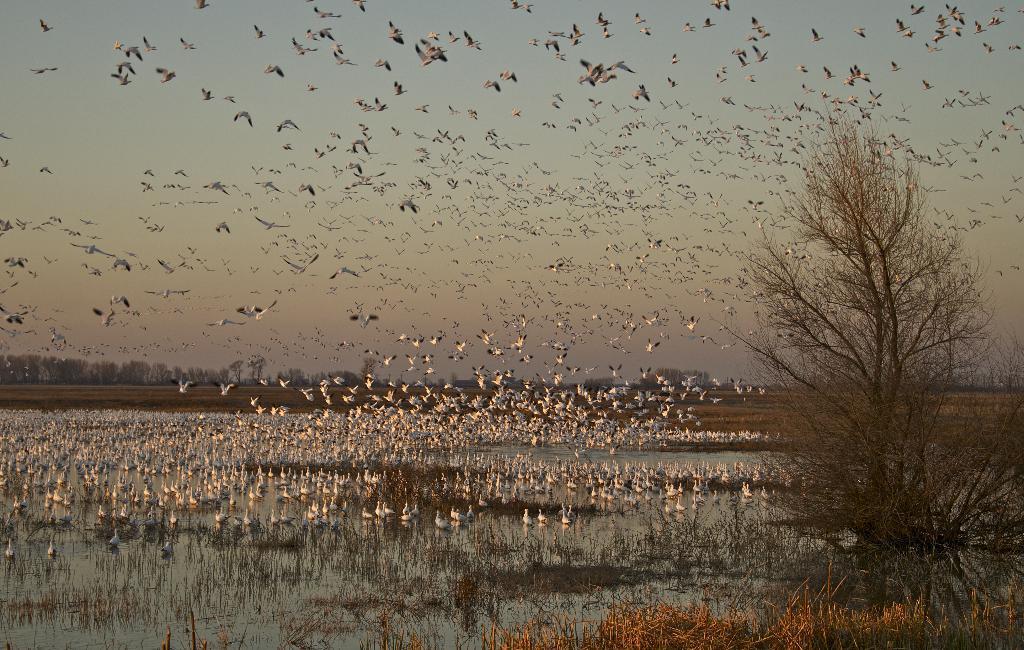In one or two sentences, can you explain what this image depicts? In this picture there are group of birds where few among them are on the water and the remaining are flying in the sky and there is greenery ground and trees in the background and there is another tree in the right corner. 